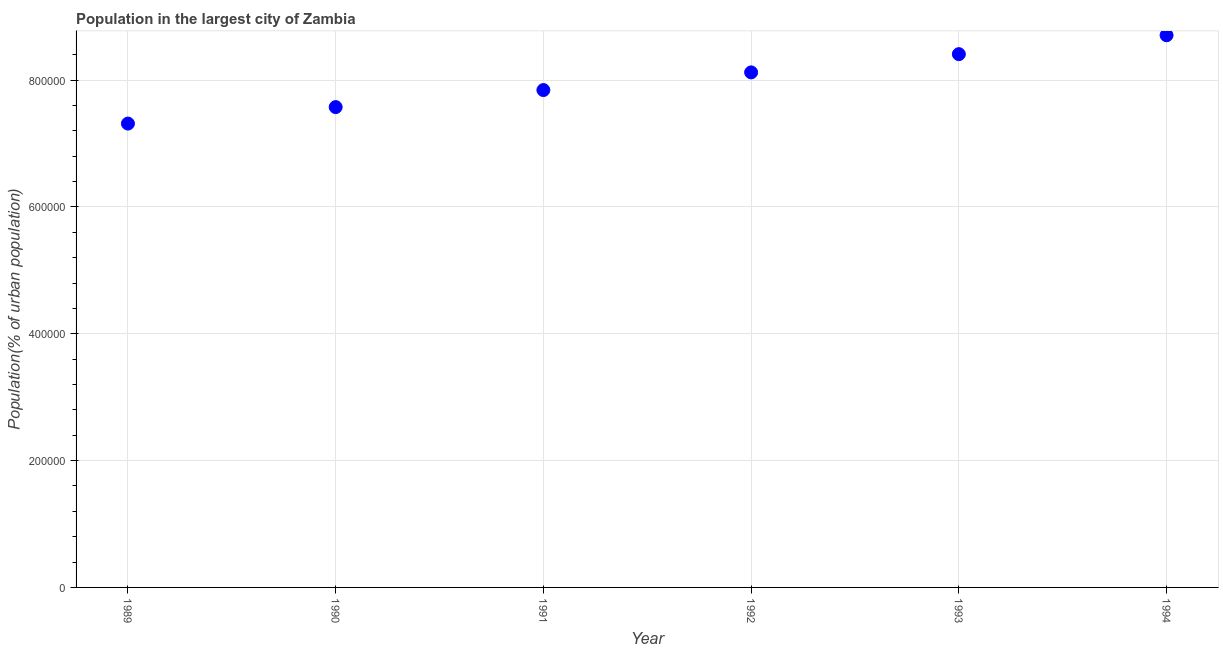What is the population in largest city in 1994?
Your answer should be very brief. 8.71e+05. Across all years, what is the maximum population in largest city?
Your answer should be very brief. 8.71e+05. Across all years, what is the minimum population in largest city?
Your answer should be compact. 7.31e+05. In which year was the population in largest city minimum?
Give a very brief answer. 1989. What is the sum of the population in largest city?
Give a very brief answer. 4.80e+06. What is the difference between the population in largest city in 1989 and 1994?
Your response must be concise. -1.39e+05. What is the average population in largest city per year?
Offer a very short reply. 7.99e+05. What is the median population in largest city?
Ensure brevity in your answer.  7.98e+05. In how many years, is the population in largest city greater than 440000 %?
Provide a short and direct response. 6. Do a majority of the years between 1992 and 1994 (inclusive) have population in largest city greater than 440000 %?
Give a very brief answer. Yes. What is the ratio of the population in largest city in 1993 to that in 1994?
Offer a terse response. 0.97. Is the population in largest city in 1989 less than that in 1994?
Your response must be concise. Yes. What is the difference between the highest and the second highest population in largest city?
Your response must be concise. 2.98e+04. What is the difference between the highest and the lowest population in largest city?
Give a very brief answer. 1.39e+05. Does the population in largest city monotonically increase over the years?
Provide a succinct answer. Yes. Are the values on the major ticks of Y-axis written in scientific E-notation?
Provide a short and direct response. No. What is the title of the graph?
Make the answer very short. Population in the largest city of Zambia. What is the label or title of the Y-axis?
Offer a very short reply. Population(% of urban population). What is the Population(% of urban population) in 1989?
Your response must be concise. 7.31e+05. What is the Population(% of urban population) in 1990?
Your answer should be very brief. 7.57e+05. What is the Population(% of urban population) in 1991?
Offer a terse response. 7.84e+05. What is the Population(% of urban population) in 1992?
Your answer should be very brief. 8.12e+05. What is the Population(% of urban population) in 1993?
Make the answer very short. 8.41e+05. What is the Population(% of urban population) in 1994?
Provide a succinct answer. 8.71e+05. What is the difference between the Population(% of urban population) in 1989 and 1990?
Your response must be concise. -2.60e+04. What is the difference between the Population(% of urban population) in 1989 and 1991?
Offer a very short reply. -5.29e+04. What is the difference between the Population(% of urban population) in 1989 and 1992?
Make the answer very short. -8.07e+04. What is the difference between the Population(% of urban population) in 1989 and 1993?
Offer a terse response. -1.09e+05. What is the difference between the Population(% of urban population) in 1989 and 1994?
Offer a very short reply. -1.39e+05. What is the difference between the Population(% of urban population) in 1990 and 1991?
Your answer should be compact. -2.69e+04. What is the difference between the Population(% of urban population) in 1990 and 1992?
Provide a short and direct response. -5.47e+04. What is the difference between the Population(% of urban population) in 1990 and 1993?
Provide a succinct answer. -8.35e+04. What is the difference between the Population(% of urban population) in 1990 and 1994?
Provide a short and direct response. -1.13e+05. What is the difference between the Population(% of urban population) in 1991 and 1992?
Ensure brevity in your answer.  -2.79e+04. What is the difference between the Population(% of urban population) in 1991 and 1993?
Provide a succinct answer. -5.66e+04. What is the difference between the Population(% of urban population) in 1991 and 1994?
Give a very brief answer. -8.64e+04. What is the difference between the Population(% of urban population) in 1992 and 1993?
Ensure brevity in your answer.  -2.88e+04. What is the difference between the Population(% of urban population) in 1992 and 1994?
Give a very brief answer. -5.86e+04. What is the difference between the Population(% of urban population) in 1993 and 1994?
Give a very brief answer. -2.98e+04. What is the ratio of the Population(% of urban population) in 1989 to that in 1991?
Ensure brevity in your answer.  0.93. What is the ratio of the Population(% of urban population) in 1989 to that in 1992?
Ensure brevity in your answer.  0.9. What is the ratio of the Population(% of urban population) in 1989 to that in 1993?
Your response must be concise. 0.87. What is the ratio of the Population(% of urban population) in 1989 to that in 1994?
Keep it short and to the point. 0.84. What is the ratio of the Population(% of urban population) in 1990 to that in 1992?
Provide a short and direct response. 0.93. What is the ratio of the Population(% of urban population) in 1990 to that in 1993?
Give a very brief answer. 0.9. What is the ratio of the Population(% of urban population) in 1990 to that in 1994?
Give a very brief answer. 0.87. What is the ratio of the Population(% of urban population) in 1991 to that in 1993?
Offer a terse response. 0.93. What is the ratio of the Population(% of urban population) in 1991 to that in 1994?
Your answer should be compact. 0.9. What is the ratio of the Population(% of urban population) in 1992 to that in 1993?
Your answer should be compact. 0.97. What is the ratio of the Population(% of urban population) in 1992 to that in 1994?
Give a very brief answer. 0.93. 